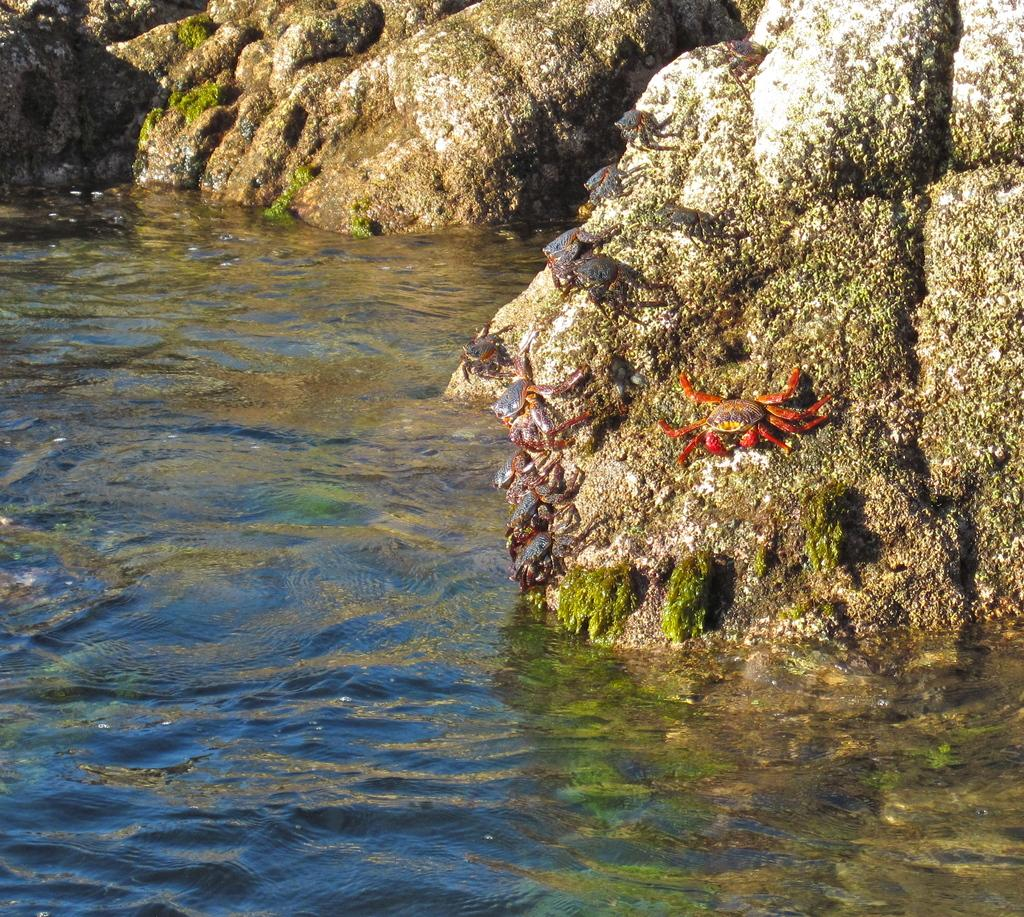What is the main feature of the image? There is a water body in the picture. What can be seen on the rock in the center of the picture? There are crabs on a rock in the center of the picture. Can you describe the rock at the top of the picture? There is a rock at the top of the picture. What type of whip is being used by the crabs in the image? There is no whip present in the image; it features a water body with crabs on a rock. 